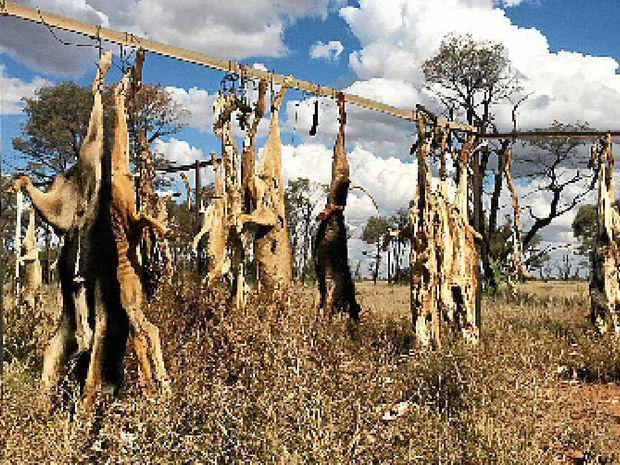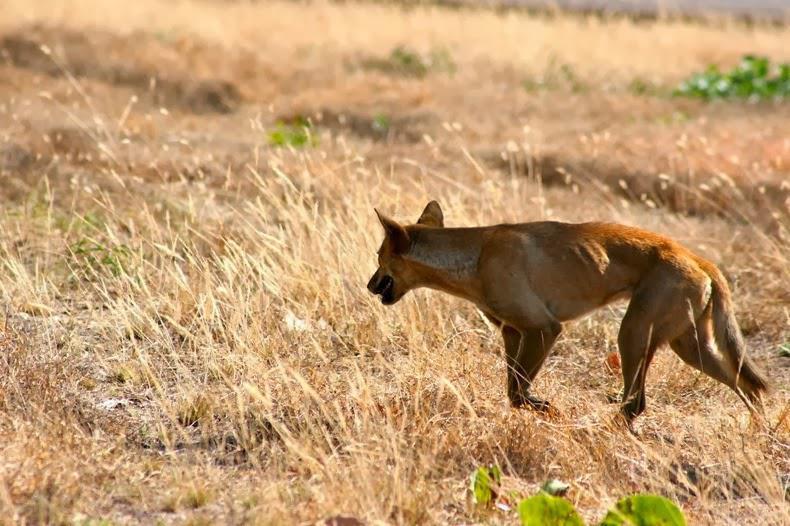The first image is the image on the left, the second image is the image on the right. Examine the images to the left and right. Is the description "An image shows one dingo standing on the ground." accurate? Answer yes or no. Yes. The first image is the image on the left, the second image is the image on the right. Given the left and right images, does the statement "There is one living animal in the image on the right." hold true? Answer yes or no. Yes. 